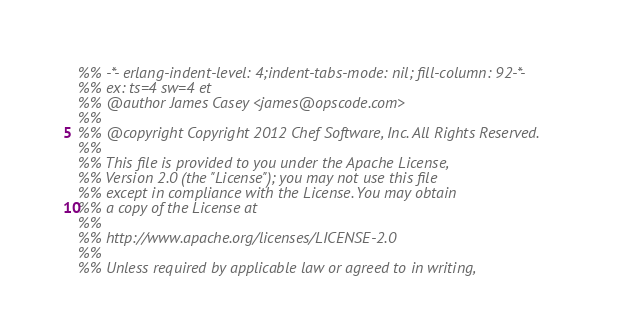Convert code to text. <code><loc_0><loc_0><loc_500><loc_500><_Erlang_>%% -*- erlang-indent-level: 4;indent-tabs-mode: nil; fill-column: 92-*-
%% ex: ts=4 sw=4 et
%% @author James Casey <james@opscode.com>
%%
%% @copyright Copyright 2012 Chef Software, Inc. All Rights Reserved.
%%
%% This file is provided to you under the Apache License,
%% Version 2.0 (the "License"); you may not use this file
%% except in compliance with the License. You may obtain
%% a copy of the License at
%%
%% http://www.apache.org/licenses/LICENSE-2.0
%%
%% Unless required by applicable law or agreed to in writing,</code> 